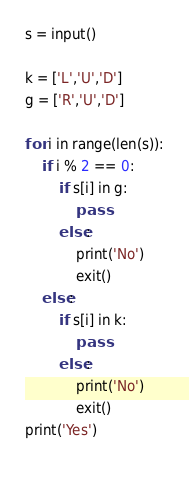Convert code to text. <code><loc_0><loc_0><loc_500><loc_500><_Python_>s = input()

k = ['L','U','D']
g = ['R','U','D']

for i in range(len(s)):
	if i % 2 == 0:
		if s[i] in g:
			pass
		else:
			print('No')
			exit()
	else:
		if s[i] in k:
			pass
		else:
			print('No')
			exit()
print('Yes')
		</code> 